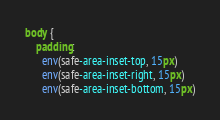<code> <loc_0><loc_0><loc_500><loc_500><_CSS_>body {
    padding:
      env(safe-area-inset-top, 15px)
      env(safe-area-inset-right, 15px)
      env(safe-area-inset-bottom, 15px)</code> 